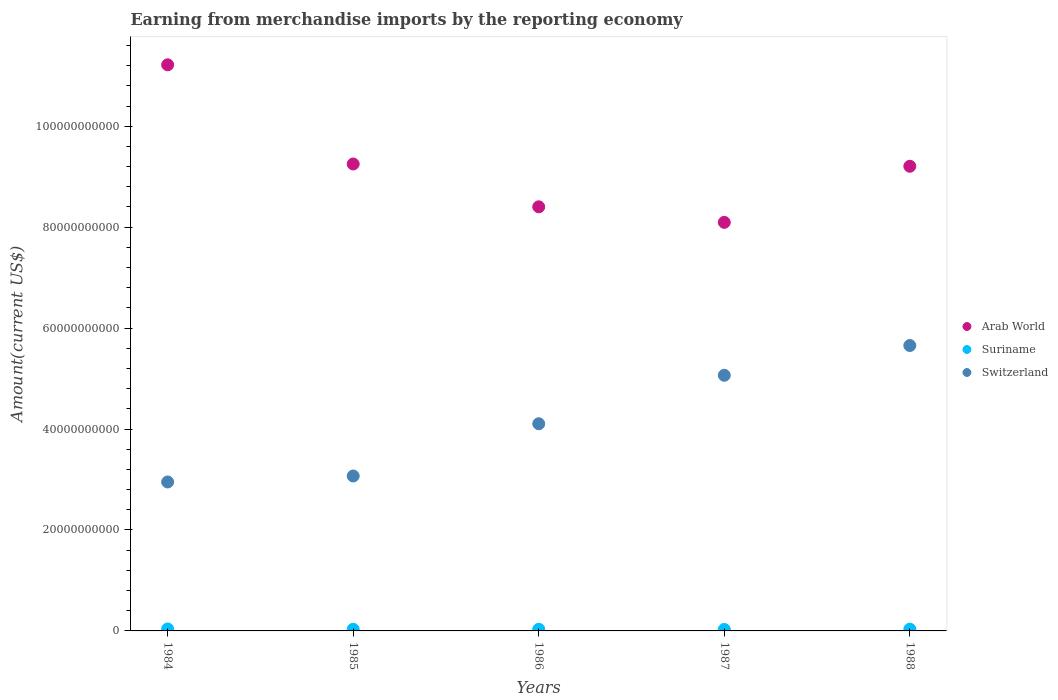What is the amount earned from merchandise imports in Suriname in 1987?
Ensure brevity in your answer.  2.95e+08. Across all years, what is the maximum amount earned from merchandise imports in Suriname?
Offer a very short reply. 3.89e+08. Across all years, what is the minimum amount earned from merchandise imports in Arab World?
Your answer should be very brief. 8.10e+1. In which year was the amount earned from merchandise imports in Switzerland minimum?
Your response must be concise. 1984. What is the total amount earned from merchandise imports in Arab World in the graph?
Ensure brevity in your answer.  4.62e+11. What is the difference between the amount earned from merchandise imports in Suriname in 1985 and that in 1988?
Your response must be concise. -2.20e+07. What is the difference between the amount earned from merchandise imports in Switzerland in 1988 and the amount earned from merchandise imports in Arab World in 1986?
Your response must be concise. -2.75e+1. What is the average amount earned from merchandise imports in Suriname per year?
Offer a terse response. 3.39e+08. In the year 1984, what is the difference between the amount earned from merchandise imports in Switzerland and amount earned from merchandise imports in Arab World?
Your response must be concise. -8.27e+1. What is the ratio of the amount earned from merchandise imports in Suriname in 1984 to that in 1987?
Your answer should be compact. 1.32. Is the difference between the amount earned from merchandise imports in Switzerland in 1984 and 1985 greater than the difference between the amount earned from merchandise imports in Arab World in 1984 and 1985?
Your answer should be compact. No. What is the difference between the highest and the second highest amount earned from merchandise imports in Switzerland?
Provide a short and direct response. 5.90e+09. What is the difference between the highest and the lowest amount earned from merchandise imports in Switzerland?
Provide a succinct answer. 2.70e+1. In how many years, is the amount earned from merchandise imports in Arab World greater than the average amount earned from merchandise imports in Arab World taken over all years?
Keep it short and to the point. 2. Is the sum of the amount earned from merchandise imports in Switzerland in 1984 and 1987 greater than the maximum amount earned from merchandise imports in Arab World across all years?
Provide a succinct answer. No. Is the amount earned from merchandise imports in Switzerland strictly greater than the amount earned from merchandise imports in Suriname over the years?
Offer a terse response. Yes. How many dotlines are there?
Provide a succinct answer. 3. How many years are there in the graph?
Ensure brevity in your answer.  5. What is the difference between two consecutive major ticks on the Y-axis?
Give a very brief answer. 2.00e+1. Where does the legend appear in the graph?
Your answer should be compact. Center right. How many legend labels are there?
Provide a short and direct response. 3. How are the legend labels stacked?
Offer a terse response. Vertical. What is the title of the graph?
Offer a terse response. Earning from merchandise imports by the reporting economy. What is the label or title of the Y-axis?
Ensure brevity in your answer.  Amount(current US$). What is the Amount(current US$) of Arab World in 1984?
Your answer should be very brief. 1.12e+11. What is the Amount(current US$) in Suriname in 1984?
Offer a very short reply. 3.89e+08. What is the Amount(current US$) of Switzerland in 1984?
Ensure brevity in your answer.  2.95e+1. What is the Amount(current US$) of Arab World in 1985?
Your answer should be compact. 9.25e+1. What is the Amount(current US$) in Suriname in 1985?
Give a very brief answer. 3.29e+08. What is the Amount(current US$) in Switzerland in 1985?
Provide a short and direct response. 3.07e+1. What is the Amount(current US$) of Arab World in 1986?
Provide a succinct answer. 8.40e+1. What is the Amount(current US$) of Suriname in 1986?
Offer a very short reply. 3.28e+08. What is the Amount(current US$) in Switzerland in 1986?
Offer a very short reply. 4.10e+1. What is the Amount(current US$) in Arab World in 1987?
Your response must be concise. 8.10e+1. What is the Amount(current US$) of Suriname in 1987?
Make the answer very short. 2.95e+08. What is the Amount(current US$) of Switzerland in 1987?
Provide a succinct answer. 5.06e+1. What is the Amount(current US$) of Arab World in 1988?
Offer a terse response. 9.21e+1. What is the Amount(current US$) of Suriname in 1988?
Offer a terse response. 3.51e+08. What is the Amount(current US$) of Switzerland in 1988?
Give a very brief answer. 5.65e+1. Across all years, what is the maximum Amount(current US$) in Arab World?
Offer a terse response. 1.12e+11. Across all years, what is the maximum Amount(current US$) in Suriname?
Offer a terse response. 3.89e+08. Across all years, what is the maximum Amount(current US$) of Switzerland?
Offer a terse response. 5.65e+1. Across all years, what is the minimum Amount(current US$) in Arab World?
Your answer should be very brief. 8.10e+1. Across all years, what is the minimum Amount(current US$) in Suriname?
Your answer should be very brief. 2.95e+08. Across all years, what is the minimum Amount(current US$) of Switzerland?
Give a very brief answer. 2.95e+1. What is the total Amount(current US$) in Arab World in the graph?
Provide a succinct answer. 4.62e+11. What is the total Amount(current US$) in Suriname in the graph?
Make the answer very short. 1.69e+09. What is the total Amount(current US$) in Switzerland in the graph?
Provide a succinct answer. 2.08e+11. What is the difference between the Amount(current US$) in Arab World in 1984 and that in 1985?
Keep it short and to the point. 1.97e+1. What is the difference between the Amount(current US$) in Suriname in 1984 and that in 1985?
Your answer should be compact. 6.03e+07. What is the difference between the Amount(current US$) in Switzerland in 1984 and that in 1985?
Your response must be concise. -1.18e+09. What is the difference between the Amount(current US$) in Arab World in 1984 and that in 1986?
Your response must be concise. 2.81e+1. What is the difference between the Amount(current US$) in Suriname in 1984 and that in 1986?
Offer a very short reply. 6.09e+07. What is the difference between the Amount(current US$) in Switzerland in 1984 and that in 1986?
Ensure brevity in your answer.  -1.15e+1. What is the difference between the Amount(current US$) of Arab World in 1984 and that in 1987?
Give a very brief answer. 3.12e+1. What is the difference between the Amount(current US$) in Suriname in 1984 and that in 1987?
Give a very brief answer. 9.47e+07. What is the difference between the Amount(current US$) of Switzerland in 1984 and that in 1987?
Give a very brief answer. -2.11e+1. What is the difference between the Amount(current US$) in Arab World in 1984 and that in 1988?
Provide a succinct answer. 2.01e+1. What is the difference between the Amount(current US$) of Suriname in 1984 and that in 1988?
Your response must be concise. 3.83e+07. What is the difference between the Amount(current US$) in Switzerland in 1984 and that in 1988?
Your answer should be compact. -2.70e+1. What is the difference between the Amount(current US$) in Arab World in 1985 and that in 1986?
Give a very brief answer. 8.49e+09. What is the difference between the Amount(current US$) of Suriname in 1985 and that in 1986?
Offer a very short reply. 6.28e+05. What is the difference between the Amount(current US$) of Switzerland in 1985 and that in 1986?
Offer a terse response. -1.04e+1. What is the difference between the Amount(current US$) in Arab World in 1985 and that in 1987?
Keep it short and to the point. 1.16e+1. What is the difference between the Amount(current US$) of Suriname in 1985 and that in 1987?
Your answer should be compact. 3.44e+07. What is the difference between the Amount(current US$) in Switzerland in 1985 and that in 1987?
Your answer should be compact. -2.00e+1. What is the difference between the Amount(current US$) of Arab World in 1985 and that in 1988?
Your answer should be very brief. 4.53e+08. What is the difference between the Amount(current US$) in Suriname in 1985 and that in 1988?
Make the answer very short. -2.20e+07. What is the difference between the Amount(current US$) in Switzerland in 1985 and that in 1988?
Give a very brief answer. -2.59e+1. What is the difference between the Amount(current US$) in Arab World in 1986 and that in 1987?
Provide a succinct answer. 3.08e+09. What is the difference between the Amount(current US$) in Suriname in 1986 and that in 1987?
Your response must be concise. 3.38e+07. What is the difference between the Amount(current US$) of Switzerland in 1986 and that in 1987?
Provide a succinct answer. -9.60e+09. What is the difference between the Amount(current US$) of Arab World in 1986 and that in 1988?
Make the answer very short. -8.03e+09. What is the difference between the Amount(current US$) in Suriname in 1986 and that in 1988?
Your answer should be compact. -2.27e+07. What is the difference between the Amount(current US$) of Switzerland in 1986 and that in 1988?
Your response must be concise. -1.55e+1. What is the difference between the Amount(current US$) of Arab World in 1987 and that in 1988?
Offer a very short reply. -1.11e+1. What is the difference between the Amount(current US$) of Suriname in 1987 and that in 1988?
Keep it short and to the point. -5.65e+07. What is the difference between the Amount(current US$) in Switzerland in 1987 and that in 1988?
Ensure brevity in your answer.  -5.90e+09. What is the difference between the Amount(current US$) in Arab World in 1984 and the Amount(current US$) in Suriname in 1985?
Offer a terse response. 1.12e+11. What is the difference between the Amount(current US$) in Arab World in 1984 and the Amount(current US$) in Switzerland in 1985?
Your answer should be compact. 8.15e+1. What is the difference between the Amount(current US$) in Suriname in 1984 and the Amount(current US$) in Switzerland in 1985?
Offer a very short reply. -3.03e+1. What is the difference between the Amount(current US$) in Arab World in 1984 and the Amount(current US$) in Suriname in 1986?
Your answer should be compact. 1.12e+11. What is the difference between the Amount(current US$) in Arab World in 1984 and the Amount(current US$) in Switzerland in 1986?
Offer a very short reply. 7.11e+1. What is the difference between the Amount(current US$) of Suriname in 1984 and the Amount(current US$) of Switzerland in 1986?
Give a very brief answer. -4.07e+1. What is the difference between the Amount(current US$) of Arab World in 1984 and the Amount(current US$) of Suriname in 1987?
Your answer should be compact. 1.12e+11. What is the difference between the Amount(current US$) in Arab World in 1984 and the Amount(current US$) in Switzerland in 1987?
Provide a short and direct response. 6.15e+1. What is the difference between the Amount(current US$) of Suriname in 1984 and the Amount(current US$) of Switzerland in 1987?
Provide a short and direct response. -5.03e+1. What is the difference between the Amount(current US$) of Arab World in 1984 and the Amount(current US$) of Suriname in 1988?
Give a very brief answer. 1.12e+11. What is the difference between the Amount(current US$) of Arab World in 1984 and the Amount(current US$) of Switzerland in 1988?
Your response must be concise. 5.56e+1. What is the difference between the Amount(current US$) in Suriname in 1984 and the Amount(current US$) in Switzerland in 1988?
Keep it short and to the point. -5.62e+1. What is the difference between the Amount(current US$) of Arab World in 1985 and the Amount(current US$) of Suriname in 1986?
Your answer should be very brief. 9.22e+1. What is the difference between the Amount(current US$) in Arab World in 1985 and the Amount(current US$) in Switzerland in 1986?
Make the answer very short. 5.15e+1. What is the difference between the Amount(current US$) in Suriname in 1985 and the Amount(current US$) in Switzerland in 1986?
Offer a terse response. -4.07e+1. What is the difference between the Amount(current US$) of Arab World in 1985 and the Amount(current US$) of Suriname in 1987?
Provide a short and direct response. 9.22e+1. What is the difference between the Amount(current US$) in Arab World in 1985 and the Amount(current US$) in Switzerland in 1987?
Make the answer very short. 4.19e+1. What is the difference between the Amount(current US$) of Suriname in 1985 and the Amount(current US$) of Switzerland in 1987?
Ensure brevity in your answer.  -5.03e+1. What is the difference between the Amount(current US$) of Arab World in 1985 and the Amount(current US$) of Suriname in 1988?
Provide a succinct answer. 9.22e+1. What is the difference between the Amount(current US$) in Arab World in 1985 and the Amount(current US$) in Switzerland in 1988?
Your response must be concise. 3.60e+1. What is the difference between the Amount(current US$) of Suriname in 1985 and the Amount(current US$) of Switzerland in 1988?
Your answer should be very brief. -5.62e+1. What is the difference between the Amount(current US$) in Arab World in 1986 and the Amount(current US$) in Suriname in 1987?
Provide a succinct answer. 8.37e+1. What is the difference between the Amount(current US$) of Arab World in 1986 and the Amount(current US$) of Switzerland in 1987?
Offer a very short reply. 3.34e+1. What is the difference between the Amount(current US$) of Suriname in 1986 and the Amount(current US$) of Switzerland in 1987?
Your answer should be compact. -5.03e+1. What is the difference between the Amount(current US$) of Arab World in 1986 and the Amount(current US$) of Suriname in 1988?
Give a very brief answer. 8.37e+1. What is the difference between the Amount(current US$) of Arab World in 1986 and the Amount(current US$) of Switzerland in 1988?
Give a very brief answer. 2.75e+1. What is the difference between the Amount(current US$) of Suriname in 1986 and the Amount(current US$) of Switzerland in 1988?
Your answer should be compact. -5.62e+1. What is the difference between the Amount(current US$) in Arab World in 1987 and the Amount(current US$) in Suriname in 1988?
Your response must be concise. 8.06e+1. What is the difference between the Amount(current US$) of Arab World in 1987 and the Amount(current US$) of Switzerland in 1988?
Your response must be concise. 2.44e+1. What is the difference between the Amount(current US$) of Suriname in 1987 and the Amount(current US$) of Switzerland in 1988?
Provide a succinct answer. -5.63e+1. What is the average Amount(current US$) of Arab World per year?
Your answer should be very brief. 9.23e+1. What is the average Amount(current US$) of Suriname per year?
Keep it short and to the point. 3.39e+08. What is the average Amount(current US$) in Switzerland per year?
Keep it short and to the point. 4.17e+1. In the year 1984, what is the difference between the Amount(current US$) of Arab World and Amount(current US$) of Suriname?
Offer a terse response. 1.12e+11. In the year 1984, what is the difference between the Amount(current US$) in Arab World and Amount(current US$) in Switzerland?
Offer a terse response. 8.27e+1. In the year 1984, what is the difference between the Amount(current US$) in Suriname and Amount(current US$) in Switzerland?
Ensure brevity in your answer.  -2.91e+1. In the year 1985, what is the difference between the Amount(current US$) in Arab World and Amount(current US$) in Suriname?
Provide a succinct answer. 9.22e+1. In the year 1985, what is the difference between the Amount(current US$) in Arab World and Amount(current US$) in Switzerland?
Ensure brevity in your answer.  6.18e+1. In the year 1985, what is the difference between the Amount(current US$) of Suriname and Amount(current US$) of Switzerland?
Give a very brief answer. -3.04e+1. In the year 1986, what is the difference between the Amount(current US$) in Arab World and Amount(current US$) in Suriname?
Your response must be concise. 8.37e+1. In the year 1986, what is the difference between the Amount(current US$) of Arab World and Amount(current US$) of Switzerland?
Provide a short and direct response. 4.30e+1. In the year 1986, what is the difference between the Amount(current US$) in Suriname and Amount(current US$) in Switzerland?
Your answer should be compact. -4.07e+1. In the year 1987, what is the difference between the Amount(current US$) of Arab World and Amount(current US$) of Suriname?
Ensure brevity in your answer.  8.07e+1. In the year 1987, what is the difference between the Amount(current US$) in Arab World and Amount(current US$) in Switzerland?
Ensure brevity in your answer.  3.03e+1. In the year 1987, what is the difference between the Amount(current US$) of Suriname and Amount(current US$) of Switzerland?
Your answer should be very brief. -5.04e+1. In the year 1988, what is the difference between the Amount(current US$) in Arab World and Amount(current US$) in Suriname?
Offer a terse response. 9.17e+1. In the year 1988, what is the difference between the Amount(current US$) in Arab World and Amount(current US$) in Switzerland?
Give a very brief answer. 3.55e+1. In the year 1988, what is the difference between the Amount(current US$) of Suriname and Amount(current US$) of Switzerland?
Offer a very short reply. -5.62e+1. What is the ratio of the Amount(current US$) in Arab World in 1984 to that in 1985?
Keep it short and to the point. 1.21. What is the ratio of the Amount(current US$) in Suriname in 1984 to that in 1985?
Give a very brief answer. 1.18. What is the ratio of the Amount(current US$) of Switzerland in 1984 to that in 1985?
Provide a short and direct response. 0.96. What is the ratio of the Amount(current US$) in Arab World in 1984 to that in 1986?
Make the answer very short. 1.33. What is the ratio of the Amount(current US$) of Suriname in 1984 to that in 1986?
Make the answer very short. 1.19. What is the ratio of the Amount(current US$) of Switzerland in 1984 to that in 1986?
Keep it short and to the point. 0.72. What is the ratio of the Amount(current US$) in Arab World in 1984 to that in 1987?
Your response must be concise. 1.39. What is the ratio of the Amount(current US$) in Suriname in 1984 to that in 1987?
Provide a short and direct response. 1.32. What is the ratio of the Amount(current US$) of Switzerland in 1984 to that in 1987?
Give a very brief answer. 0.58. What is the ratio of the Amount(current US$) in Arab World in 1984 to that in 1988?
Provide a succinct answer. 1.22. What is the ratio of the Amount(current US$) in Suriname in 1984 to that in 1988?
Make the answer very short. 1.11. What is the ratio of the Amount(current US$) in Switzerland in 1984 to that in 1988?
Your answer should be very brief. 0.52. What is the ratio of the Amount(current US$) of Arab World in 1985 to that in 1986?
Your answer should be compact. 1.1. What is the ratio of the Amount(current US$) in Suriname in 1985 to that in 1986?
Provide a succinct answer. 1. What is the ratio of the Amount(current US$) in Switzerland in 1985 to that in 1986?
Your answer should be compact. 0.75. What is the ratio of the Amount(current US$) in Suriname in 1985 to that in 1987?
Offer a very short reply. 1.12. What is the ratio of the Amount(current US$) of Switzerland in 1985 to that in 1987?
Ensure brevity in your answer.  0.61. What is the ratio of the Amount(current US$) of Suriname in 1985 to that in 1988?
Provide a short and direct response. 0.94. What is the ratio of the Amount(current US$) in Switzerland in 1985 to that in 1988?
Ensure brevity in your answer.  0.54. What is the ratio of the Amount(current US$) in Arab World in 1986 to that in 1987?
Your answer should be very brief. 1.04. What is the ratio of the Amount(current US$) of Suriname in 1986 to that in 1987?
Provide a succinct answer. 1.11. What is the ratio of the Amount(current US$) of Switzerland in 1986 to that in 1987?
Provide a succinct answer. 0.81. What is the ratio of the Amount(current US$) of Arab World in 1986 to that in 1988?
Your answer should be very brief. 0.91. What is the ratio of the Amount(current US$) of Suriname in 1986 to that in 1988?
Give a very brief answer. 0.94. What is the ratio of the Amount(current US$) in Switzerland in 1986 to that in 1988?
Keep it short and to the point. 0.73. What is the ratio of the Amount(current US$) of Arab World in 1987 to that in 1988?
Provide a short and direct response. 0.88. What is the ratio of the Amount(current US$) of Suriname in 1987 to that in 1988?
Your answer should be very brief. 0.84. What is the ratio of the Amount(current US$) in Switzerland in 1987 to that in 1988?
Give a very brief answer. 0.9. What is the difference between the highest and the second highest Amount(current US$) of Arab World?
Your response must be concise. 1.97e+1. What is the difference between the highest and the second highest Amount(current US$) of Suriname?
Give a very brief answer. 3.83e+07. What is the difference between the highest and the second highest Amount(current US$) of Switzerland?
Make the answer very short. 5.90e+09. What is the difference between the highest and the lowest Amount(current US$) in Arab World?
Your answer should be very brief. 3.12e+1. What is the difference between the highest and the lowest Amount(current US$) of Suriname?
Ensure brevity in your answer.  9.47e+07. What is the difference between the highest and the lowest Amount(current US$) in Switzerland?
Make the answer very short. 2.70e+1. 